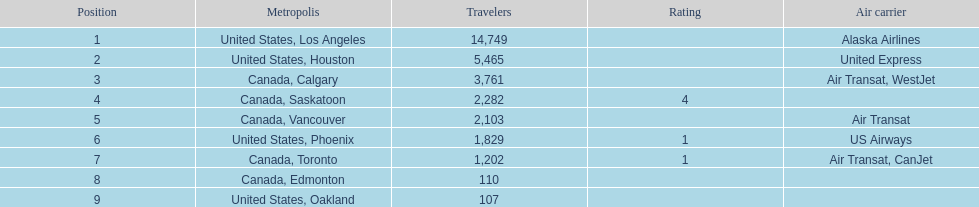The least number of passengers came from which city United States, Oakland. 